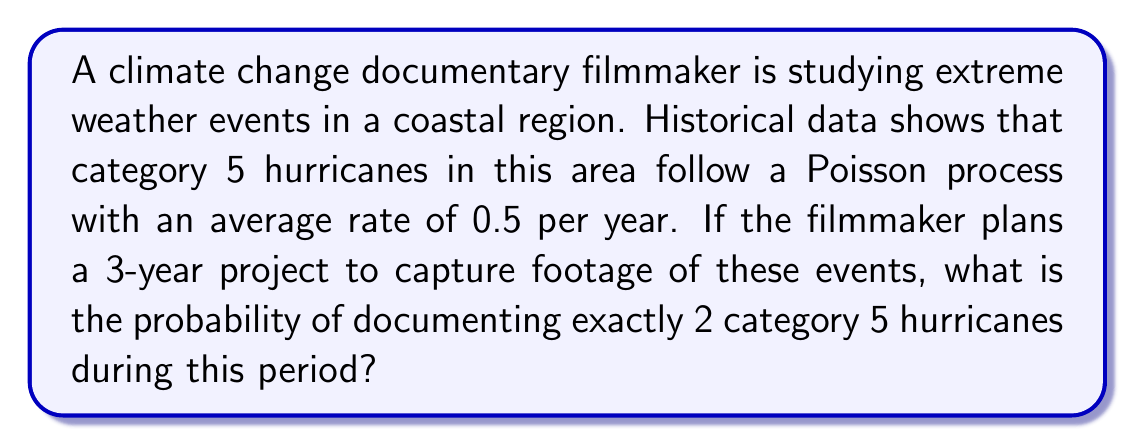Give your solution to this math problem. To solve this problem, we'll use the Poisson distribution formula:

$$P(X = k) = \frac{e^{-\lambda} \lambda^k}{k!}$$

Where:
$\lambda$ = average rate of events * time period
$k$ = number of events we're interested in
$e$ = Euler's number (approximately 2.71828)

Step 1: Calculate $\lambda$
$\lambda = 0.5 \text{ hurricanes/year} \times 3 \text{ years} = 1.5$

Step 2: Plug values into the Poisson formula
$P(X = 2) = \frac{e^{-1.5} 1.5^2}{2!}$

Step 3: Simplify
$P(X = 2) = \frac{e^{-1.5} \times 2.25}{2}$

Step 4: Calculate
$P(X = 2) = \frac{0.22313 \times 2.25}{2} \approx 0.2510$

Step 5: Convert to percentage
$0.2510 \times 100\% = 25.10\%$
Answer: 25.10% 